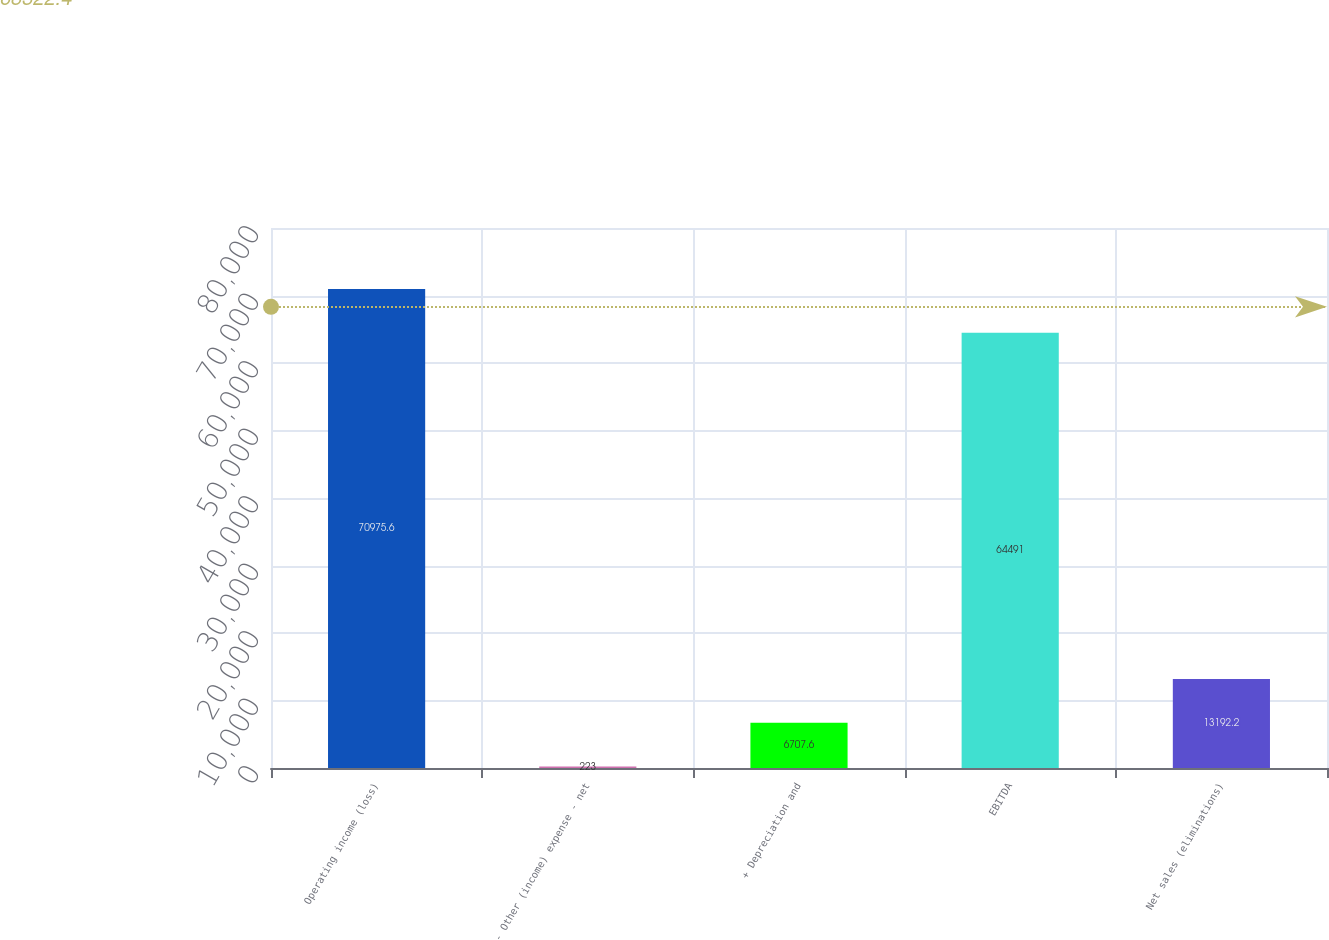Convert chart. <chart><loc_0><loc_0><loc_500><loc_500><bar_chart><fcel>Operating income (loss)<fcel>- Other (income) expense - net<fcel>+ Depreciation and<fcel>EBITDA<fcel>Net sales (eliminations)<nl><fcel>70975.6<fcel>223<fcel>6707.6<fcel>64491<fcel>13192.2<nl></chart> 